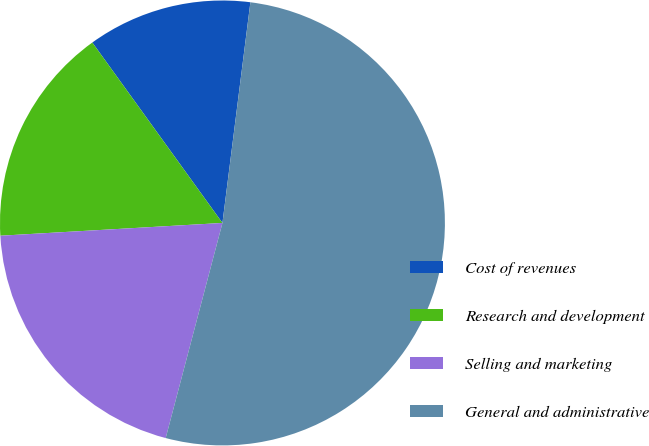Convert chart. <chart><loc_0><loc_0><loc_500><loc_500><pie_chart><fcel>Cost of revenues<fcel>Research and development<fcel>Selling and marketing<fcel>General and administrative<nl><fcel>11.95%<fcel>15.97%<fcel>19.98%<fcel>52.1%<nl></chart> 